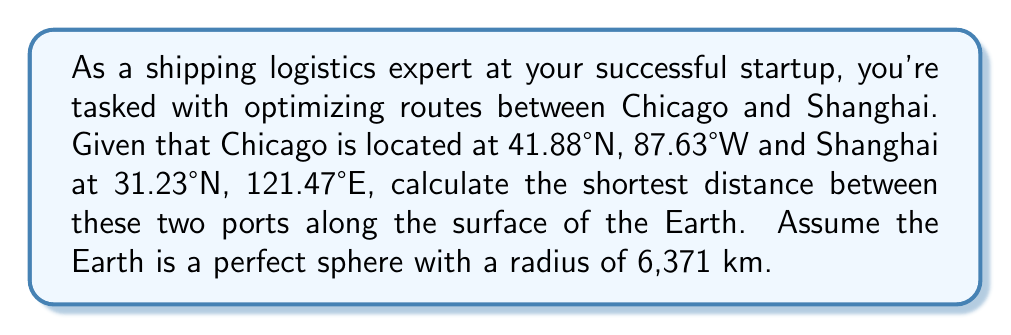Solve this math problem. To solve this problem, we'll use the great-circle distance formula, which gives the shortest distance between two points on a sphere. This approach aligns with the optimization skills honed at the University of Chicago.

1) First, we need to convert the coordinates to radians:

   Chicago: $\phi_1 = 41.88° \times \frac{\pi}{180} = 0.7309$ rad
             $\lambda_1 = -87.63° \times \frac{\pi}{180} = -1.5297$ rad
   
   Shanghai: $\phi_2 = 31.23° \times \frac{\pi}{180} = 0.5451$ rad
              $\lambda_2 = 121.47° \times \frac{\pi}{180} = 2.1199$ rad

2) The great-circle distance formula is:

   $$d = r \times \arccos(\sin\phi_1 \sin\phi_2 + \cos\phi_1 \cos\phi_2 \cos(\lambda_2 - \lambda_1))$$

   Where $r$ is the radius of the Earth, $\phi$ is latitude, and $\lambda$ is longitude.

3) Let's calculate each part:

   $\sin\phi_1 \sin\phi_2 = \sin(0.7309) \sin(0.5451) = 0.3377$
   
   $\cos\phi_1 \cos\phi_2 = \cos(0.7309) \cos(0.5451) = 0.5955$
   
   $\cos(\lambda_2 - \lambda_1) = \cos(2.1199 - (-1.5297)) = \cos(3.6496) = -0.8052$

4) Substituting into the formula:

   $$d = 6371 \times \arccos(0.3377 + 0.5955 \times (-0.8052))$$
   $$d = 6371 \times \arccos(-0.1419)$$
   $$d = 6371 \times 1.7124$$
   $$d = 10,909.7 \text{ km}$$

5) Rounding to the nearest kilometer:

   $$d \approx 10,910 \text{ km}$$
Answer: The shortest distance between Chicago and Shanghai along the Earth's surface is approximately 10,910 km. 